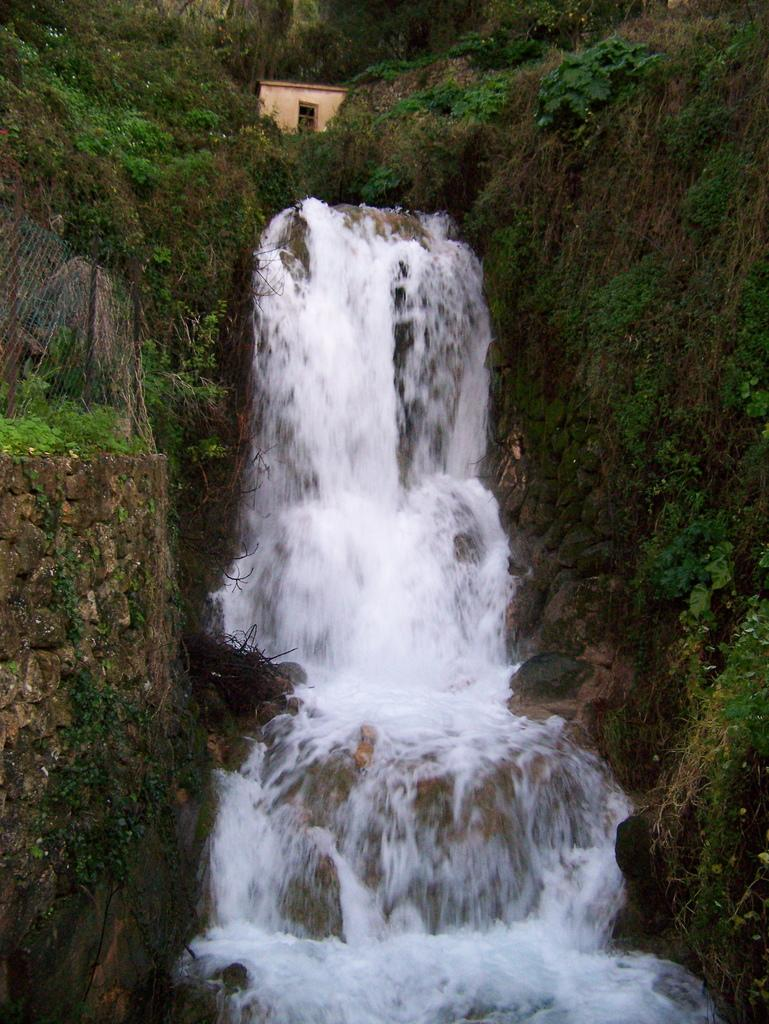What natural feature is present in the image? There is a waterfall in the image. What type of vegetation can be seen in the image? There is grass in the image. What man-made structures are present in the image? There is a stone wall and a fence in the image. What type of building is visible in the image? There is a small house in the image. How many chains are attached to the waterfall in the image? There are no chains attached to the waterfall in the image. What type of wire is used to create the fence in the image? There is no wire used to create the fence in the image; it is made of a different material. 